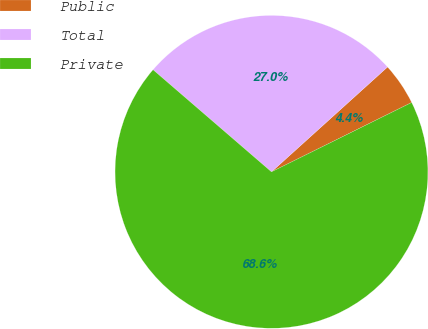Convert chart. <chart><loc_0><loc_0><loc_500><loc_500><pie_chart><fcel>Public<fcel>Total<fcel>Private<nl><fcel>4.38%<fcel>26.98%<fcel>68.64%<nl></chart> 